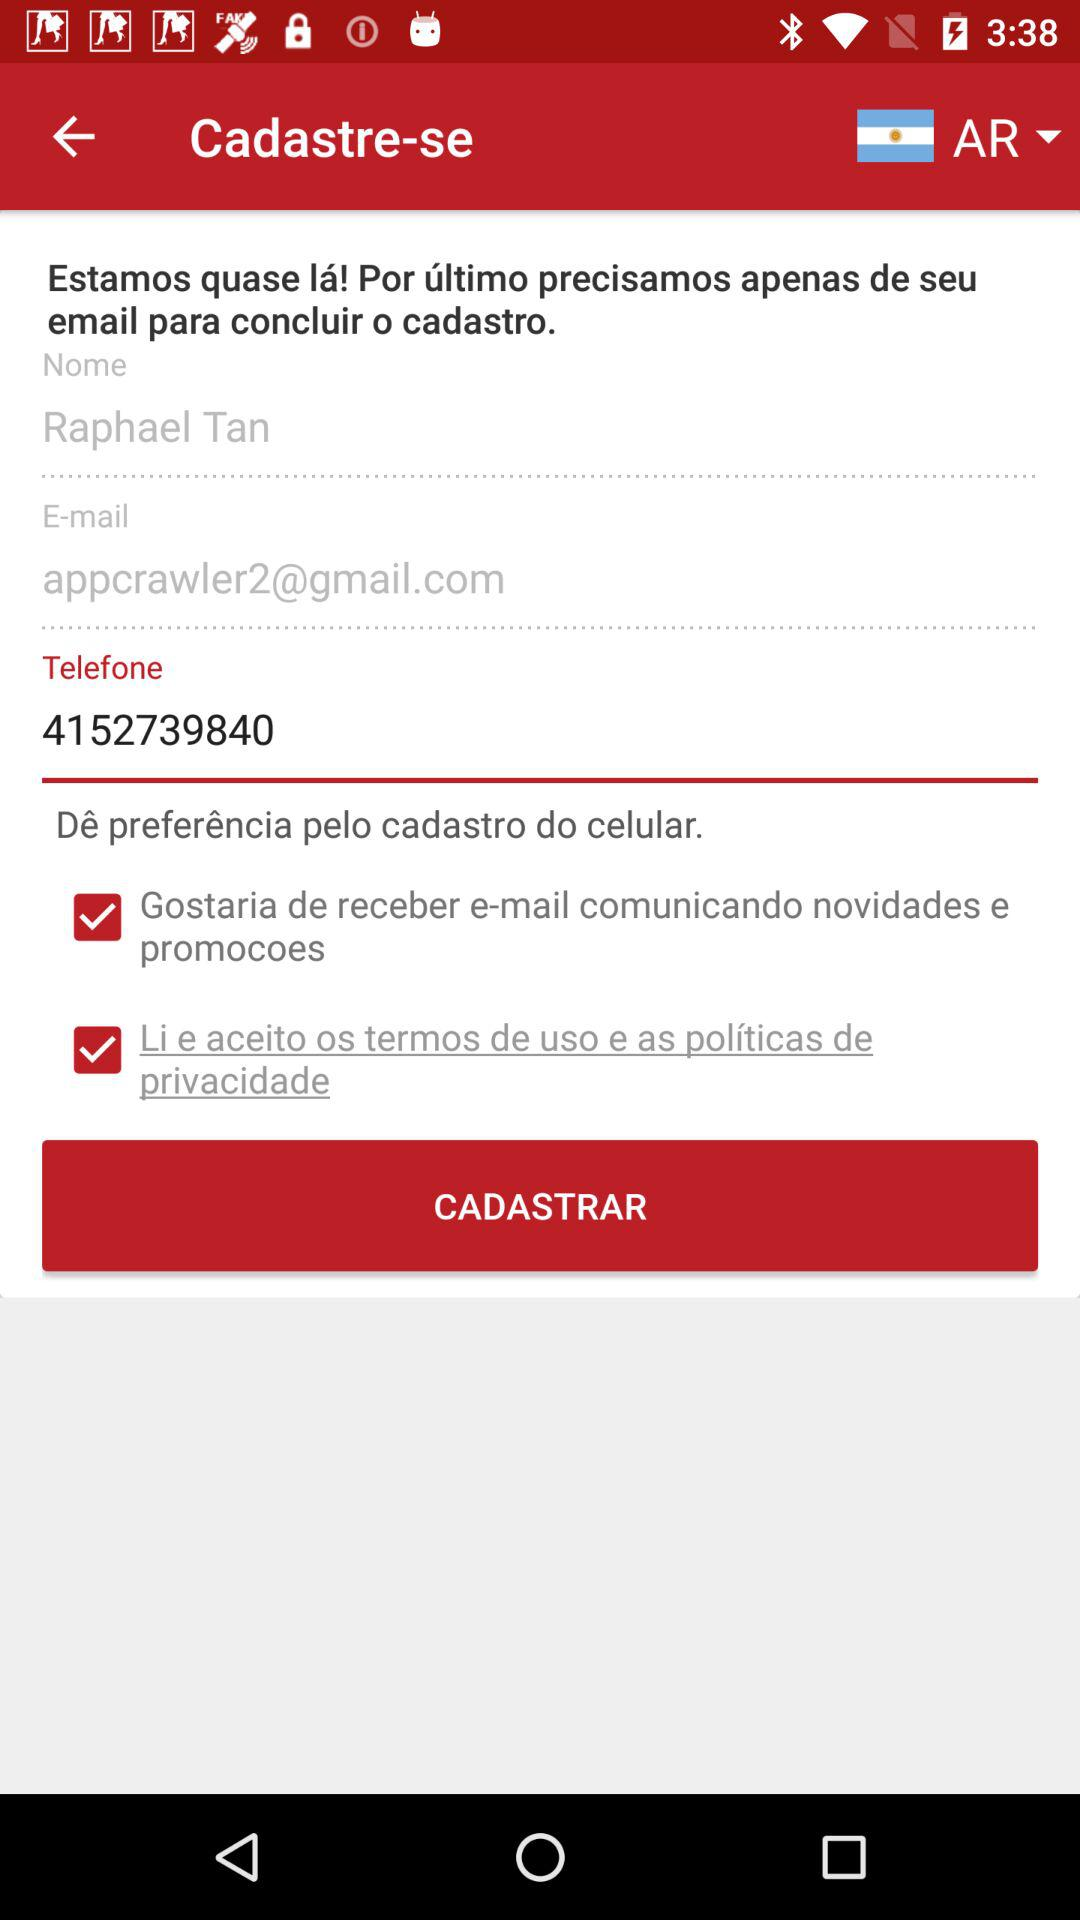How many text inputs have an email address?
Answer the question using a single word or phrase. 1 